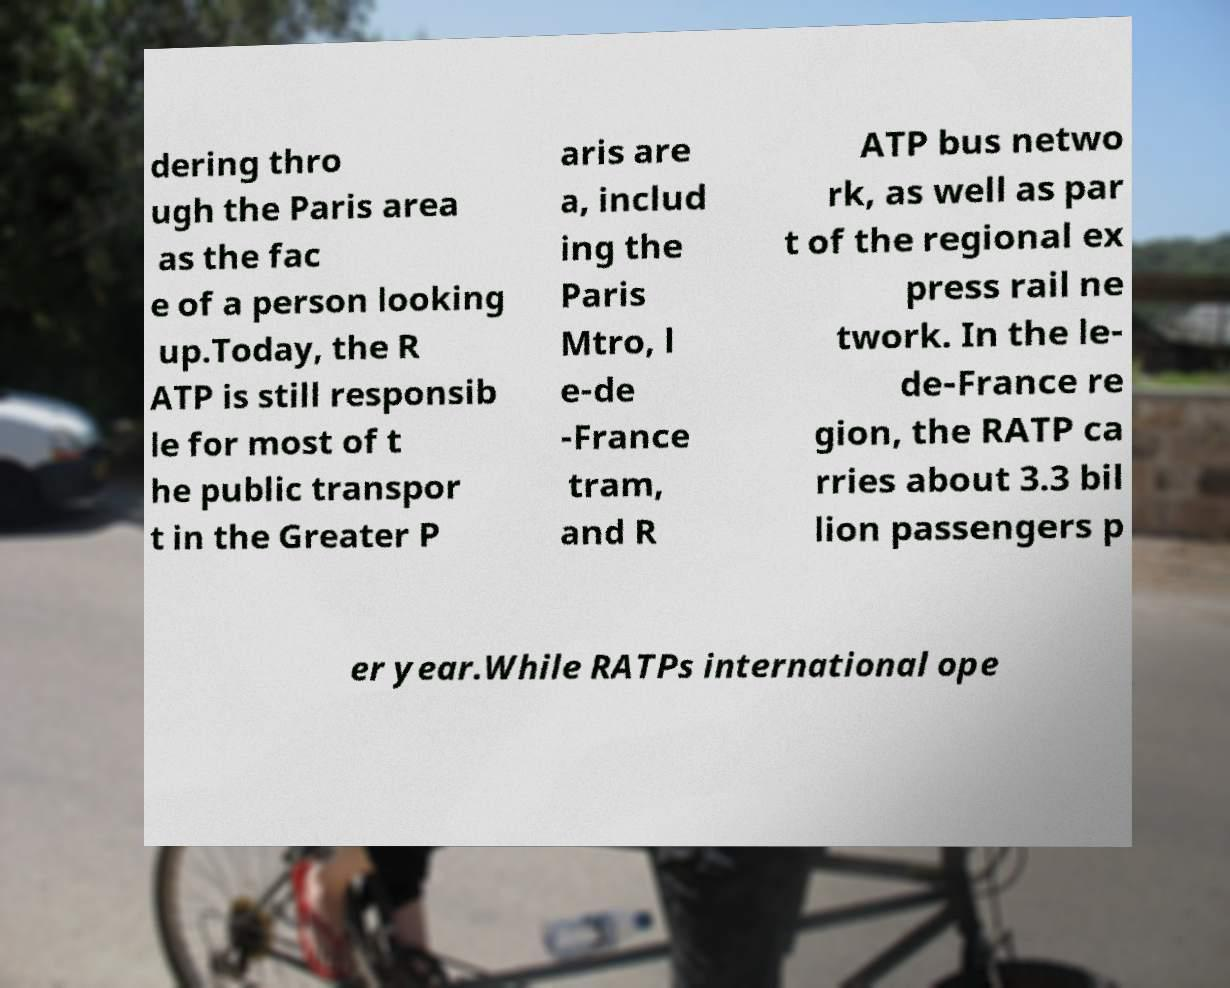Can you read and provide the text displayed in the image?This photo seems to have some interesting text. Can you extract and type it out for me? dering thro ugh the Paris area as the fac e of a person looking up.Today, the R ATP is still responsib le for most of t he public transpor t in the Greater P aris are a, includ ing the Paris Mtro, l e-de -France tram, and R ATP bus netwo rk, as well as par t of the regional ex press rail ne twork. In the le- de-France re gion, the RATP ca rries about 3.3 bil lion passengers p er year.While RATPs international ope 